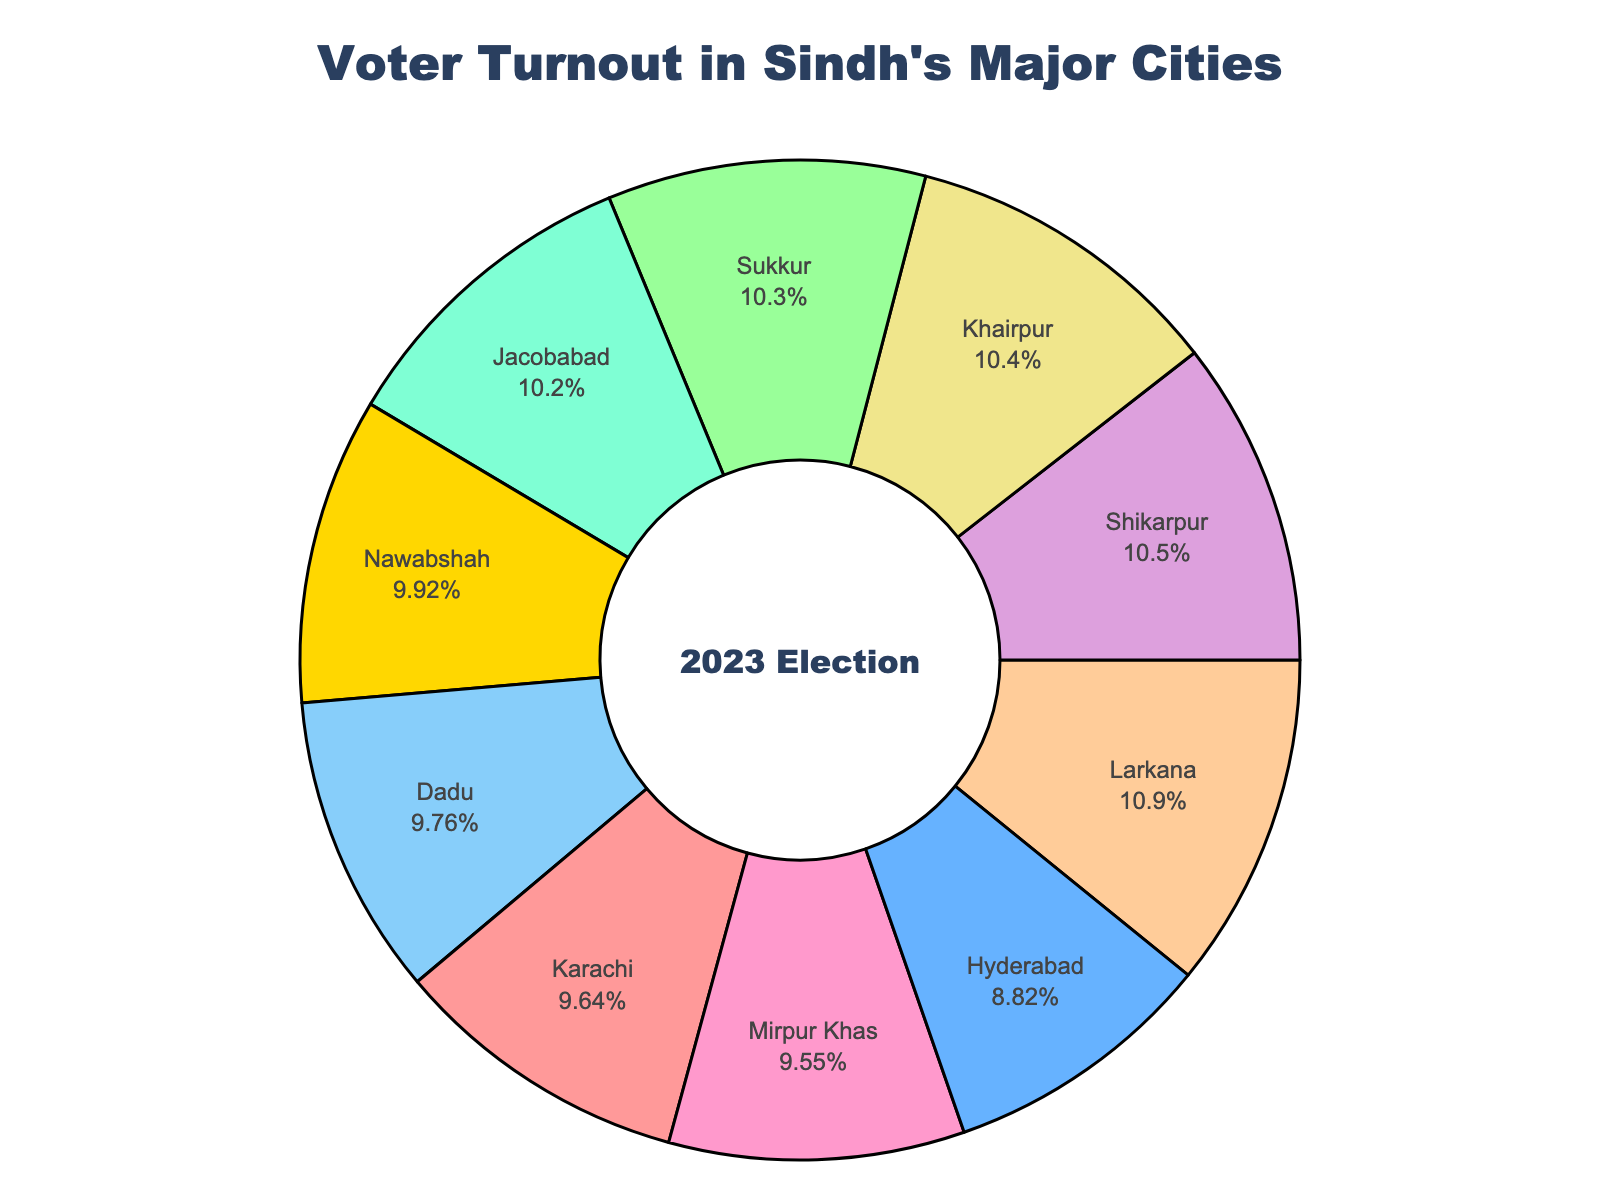What is the city with the highest voter turnout percentage? Based on the pie chart, find the label with the largest percentage segment. Larkana has the highest voter turnout percentage at 47.6%.
Answer: Larkana Which city has the lowest voter turnout percentage? Look for the segment in the pie chart with the smallest percentage value. Hyderabad has the lowest turnout at 38.7%.
Answer: Hyderabad Compare the voter turnout percentages of Karachi and Sukkur. Which one is higher, and by how much? Identify the segments for Karachi and Sukkur, observe their percentages. Sukkur has 45.1% and Karachi has 42.3%, so Sukkur is higher by 2.8%.
Answer: Sukkur, by 2.8% What is the average voter turnout percentage for all the cities? Sum the voter turnout percentages for all cities and divide by the number of cities. (42.3 + 38.7 + 45.1 + 47.6 + 41.9 + 43.5 + 44.8 + 46.2 + 45.7 + 42.8) / 10 = 43.86%
Answer: 43.86% Which city has a voter turnout percentage closest to the average? Calculate the average turnout percentage (43.86%), then find the city whose turnout percentage is closest to this average value. Dadu's turnout is 42.8%, which is the closest to the average.
Answer: Dadu What is the total combined percentage of voter turnout for Larkana and Shikarpur? Find the values for Larkana and Shikarpur and add them up. Larkana is 47.6% and Shikarpur is 46.2%, so the total is 47.6% + 46.2% = 93.8%.
Answer: 93.8% How many cities have a voter turnout percentage greater than 45%? Identify segments in the pie chart with percentages greater than 45%. The cities are Sukkur, Larkana, Shikarpur, and Khairpur, totaling 4 cities.
Answer: 4 What is the difference between the highest and lowest voter turnout percentages? Find the highest and lowest turnout percentages from the chart, then subtract the smallest from the largest. The highest is 47.6% and the lowest is 38.7%, so the difference is 47.6% - 38.7% = 8.9%.
Answer: 8.9% Are there more cities with voter turnout percentages below 45% or at or above 45%? Count the number of cities in each category based on the pie chart. Below 45%: 5 cities (Karachi, Hyderabad, Mirpur Khas, Nawabshah, Dadu). At or above 45%: 5 cities (Sukkur, Larkana, Jacobabad, Shikarpur, Khairpur). It’s equal.
Answer: Equal Which color represents Karachi’s voter turnout percentage in the pie chart? Identify the color segment that is labeled 'Karachi'. The color for Karachi is red.
Answer: Red 